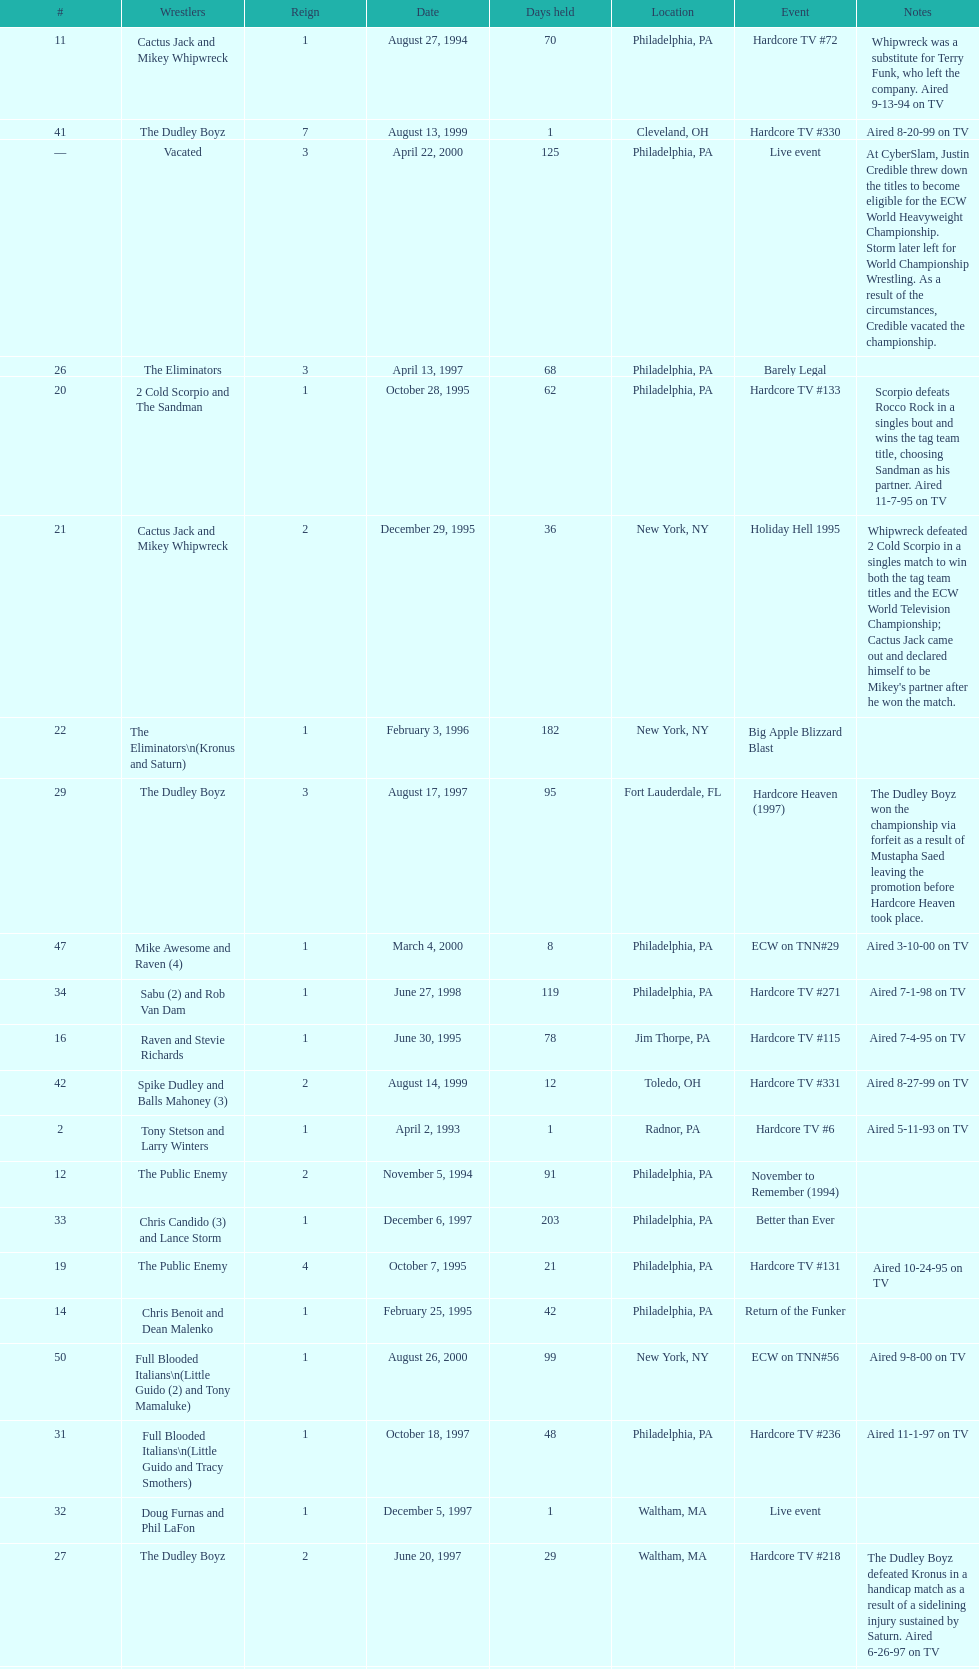What is the next event after hardcore tv #15? Hardcore TV #21. Could you parse the entire table? {'header': ['#', 'Wrestlers', 'Reign', 'Date', 'Days held', 'Location', 'Event', 'Notes'], 'rows': [['11', 'Cactus Jack and Mikey Whipwreck', '1', 'August 27, 1994', '70', 'Philadelphia, PA', 'Hardcore TV #72', 'Whipwreck was a substitute for Terry Funk, who left the company. Aired 9-13-94 on TV'], ['41', 'The Dudley Boyz', '7', 'August 13, 1999', '1', 'Cleveland, OH', 'Hardcore TV #330', 'Aired 8-20-99 on TV'], ['—', 'Vacated', '3', 'April 22, 2000', '125', 'Philadelphia, PA', 'Live event', 'At CyberSlam, Justin Credible threw down the titles to become eligible for the ECW World Heavyweight Championship. Storm later left for World Championship Wrestling. As a result of the circumstances, Credible vacated the championship.'], ['26', 'The Eliminators', '3', 'April 13, 1997', '68', 'Philadelphia, PA', 'Barely Legal', ''], ['20', '2 Cold Scorpio and The Sandman', '1', 'October 28, 1995', '62', 'Philadelphia, PA', 'Hardcore TV #133', 'Scorpio defeats Rocco Rock in a singles bout and wins the tag team title, choosing Sandman as his partner. Aired 11-7-95 on TV'], ['21', 'Cactus Jack and Mikey Whipwreck', '2', 'December 29, 1995', '36', 'New York, NY', 'Holiday Hell 1995', "Whipwreck defeated 2 Cold Scorpio in a singles match to win both the tag team titles and the ECW World Television Championship; Cactus Jack came out and declared himself to be Mikey's partner after he won the match."], ['22', 'The Eliminators\\n(Kronus and Saturn)', '1', 'February 3, 1996', '182', 'New York, NY', 'Big Apple Blizzard Blast', ''], ['29', 'The Dudley Boyz', '3', 'August 17, 1997', '95', 'Fort Lauderdale, FL', 'Hardcore Heaven (1997)', 'The Dudley Boyz won the championship via forfeit as a result of Mustapha Saed leaving the promotion before Hardcore Heaven took place.'], ['47', 'Mike Awesome and Raven (4)', '1', 'March 4, 2000', '8', 'Philadelphia, PA', 'ECW on TNN#29', 'Aired 3-10-00 on TV'], ['34', 'Sabu (2) and Rob Van Dam', '1', 'June 27, 1998', '119', 'Philadelphia, PA', 'Hardcore TV #271', 'Aired 7-1-98 on TV'], ['16', 'Raven and Stevie Richards', '1', 'June 30, 1995', '78', 'Jim Thorpe, PA', 'Hardcore TV #115', 'Aired 7-4-95 on TV'], ['42', 'Spike Dudley and Balls Mahoney (3)', '2', 'August 14, 1999', '12', 'Toledo, OH', 'Hardcore TV #331', 'Aired 8-27-99 on TV'], ['2', 'Tony Stetson and Larry Winters', '1', 'April 2, 1993', '1', 'Radnor, PA', 'Hardcore TV #6', 'Aired 5-11-93 on TV'], ['12', 'The Public Enemy', '2', 'November 5, 1994', '91', 'Philadelphia, PA', 'November to Remember (1994)', ''], ['33', 'Chris Candido (3) and Lance Storm', '1', 'December 6, 1997', '203', 'Philadelphia, PA', 'Better than Ever', ''], ['19', 'The Public Enemy', '4', 'October 7, 1995', '21', 'Philadelphia, PA', 'Hardcore TV #131', 'Aired 10-24-95 on TV'], ['14', 'Chris Benoit and Dean Malenko', '1', 'February 25, 1995', '42', 'Philadelphia, PA', 'Return of the Funker', ''], ['50', 'Full Blooded Italians\\n(Little Guido (2) and Tony Mamaluke)', '1', 'August 26, 2000', '99', 'New York, NY', 'ECW on TNN#56', 'Aired 9-8-00 on TV'], ['31', 'Full Blooded Italians\\n(Little Guido and Tracy Smothers)', '1', 'October 18, 1997', '48', 'Philadelphia, PA', 'Hardcore TV #236', 'Aired 11-1-97 on TV'], ['32', 'Doug Furnas and Phil LaFon', '1', 'December 5, 1997', '1', 'Waltham, MA', 'Live event', ''], ['27', 'The Dudley Boyz', '2', 'June 20, 1997', '29', 'Waltham, MA', 'Hardcore TV #218', 'The Dudley Boyz defeated Kronus in a handicap match as a result of a sidelining injury sustained by Saturn. Aired 6-26-97 on TV'], ['17', 'The Pitbulls\\n(Pitbull #1 and Pitbull #2)', '1', 'September 16, 1995', '21', 'Philadelphia, PA', "Gangsta's Paradise", ''], ['—', 'Vacated', '1', 'July 1993', '39', 'N/A', 'N/A', 'ECW vacated the title after Candido left the promotion for the Smoky Mountain Wrestling organization.'], ['15', 'The Public Enemy', '3', 'April 8, 1995', '83', 'Philadelphia, PA', 'Three Way Dance', 'Also def. Rick Steiner (who was a substitute for Sabu) and Taz in 3 way dance'], ['28', 'The Gangstas', '2', 'July 19, 1997', '29', 'Philadelphia, PA', 'Heat Wave 1997/Hardcore TV #222', 'Aired 7-24-97 on TV'], ['4', 'The Super Destroyers', '2', 'May 15, 1993', '0', 'Philadelphia, PA', 'Hardcore TV #14', 'Aired 7-6-93 on TV'], ['40', 'Spike Dudley and Balls Mahoney (2)', '1', 'July 18, 1999', '26', 'Dayton, OH', 'Heat Wave (1999)', ''], ['49', 'Yoshihiro Tajiri and Mikey Whipwreck (3)', '1', 'August 25, 2000', '1', 'New York, NY', 'ECW on TNN#55', 'Aired 9-1-00 on TV'], ['13', 'Sabu and The Tazmaniac (2)', '1', 'February 4, 1995', '21', 'Philadelphia, PA', 'Double Tables', ''], ['24', 'The Eliminators', '2', 'December 20, 1996', '85', 'Middletown, NY', 'Hardcore TV #193', 'Aired on 12/31/96 on Hardcore TV'], ['3', 'The Suicide Blondes\\n(Chris Candido, Johnny Hotbody, and Chris Michaels)', '1', 'April 3, 1993', '42', 'Philadelphia, PA', 'Hardcore TV #8', 'All three wrestlers were recognized as champions, and were able to defend the titles in any combination via the Freebird rule. Aired 5-25-93 on TV'], ['43', 'The Dudley Boyz', '8', 'August 26, 1999', '0', 'New York, NY', 'ECW on TNN#2', 'Aired 9-3-99 on TV'], ['1', 'The Super Destroyers\\n(A.J. Petrucci and Doug Stahl)', '1', 'June 23, 1992', '283', 'Philadelphia, PA', 'Live event', 'Petrucci and Stahl won the titles in a tournament final.'], ['6', 'The Dark Patriot and Eddie Gilbert', '1', 'August 8, 1993', '54', 'Philadelphia, PA', 'Hardcore TV #21', 'The Dark Patriot and Gilbert won the titles in a tournament final. Aired 9-7-93 on TV'], ['18', 'Raven and Stevie Richards', '2', 'October 7, 1995', '0', 'Philadelphia, PA', 'Hardcore TV #131', 'Aired 10-24-95 on TV'], ['51', 'Danny Doring and Roadkill', '1', 'December 3, 2000', '122', 'New York, NY', 'Massacre on 34th Street', "Doring and Roadkill's reign was the final one in the title's history."], ['38', 'Sabu (3) and Rob Van Dam', '2', 'December 13, 1998', '125', 'Tokyo, Japan', 'ECW/FMW Supershow II', 'Aired 12-16-98 on TV'], ['10', 'The Public Enemy\\n(Johnny Grunge and Rocco Rock)', '1', 'March 6, 1994', '174', 'Philadelphia, PA', 'Hardcore TV #46', 'Aired 3-8-94 on TV'], ['46', 'Tommy Dreamer (3) and Masato Tanaka (2)', '1', 'February 26, 2000', '7', 'Cincinnati, OH', 'Hardcore TV #358', 'Aired 3-7-00 on TV'], ['39', 'The Dudley Boyz', '6', 'April 17, 1999', '92', 'Buffalo, NY', 'Hardcore TV #313', 'D-Von Dudley defeated Van Dam in a singles match to win the championship for his team. Aired 4-23-99 on TV'], ['9', 'Kevin Sullivan and The Tazmaniac', '1', 'December 4, 1993', '92', 'Philadelphia, PA', 'Hardcore TV #35', 'Defeat Dreamer and Shane Douglas, who was substituting for an injured Gunn. After the bout, Douglas turned against Dreamer and became a heel. Aired 12-14-93 on TV'], ['36', 'Balls Mahoney and Masato Tanaka', '1', 'November 1, 1998', '5', 'New Orleans, LA', 'November to Remember (1998)', ''], ['45', 'Impact Players\\n(Justin Credible and Lance Storm (2))', '1', 'January 9, 2000', '48', 'Birmingham, AL', 'Guilty as Charged (2000)', ''], ['30', 'The Gangstanators\\n(Kronus (4) and New Jack (3))', '1', 'September 20, 1997', '28', 'Philadelphia, PA', 'As Good as it Gets', 'Aired 9-27-97 on TV'], ['8', 'Tommy Dreamer and Johnny Gunn', '1', 'November 13, 1993', '21', 'Philadelphia, PA', 'November to Remember (1993)', ''], ['5', 'The Suicide Blondes', '2', 'May 15, 1993', '46', 'Philadelphia, PA', 'Hardcore TV #15', 'Aired 7-20-93 on TV'], ['—', 'Vacated', '2', 'October 1, 1993', '0', 'Philadelphia, PA', 'Bloodfest: Part 1', 'ECW vacated the championships after The Dark Patriot and Eddie Gilbert left the organization.'], ['37', 'The Dudley Boyz', '5', 'November 6, 1998', '37', 'New York, NY', 'Hardcore TV #290', 'Aired 11-11-98 on TV'], ['7', 'Johnny Hotbody (3) and Tony Stetson (2)', '1', 'October 1, 1993', '43', 'Philadelphia, PA', 'Bloodfest: Part 1', 'Hotbody and Stetson were awarded the titles by ECW.'], ['25', 'The Dudley Boyz\\n(Buh Buh Ray Dudley and D-Von Dudley)', '1', 'March 15, 1997', '29', 'Philadelphia, PA', 'Hostile City Showdown', 'Aired 3/20/97 on Hardcore TV'], ['44', 'Tommy Dreamer (2) and Raven (3)', '1', 'August 26, 1999', '136', 'New York, NY', 'ECW on TNN#2', 'Aired 9-3-99 on TV'], ['23', 'The Gangstas\\n(Mustapha Saed and New Jack)', '1', 'August 3, 1996', '139', 'Philadelphia, PA', 'Doctor Is In', ''], ['48', 'Impact Players\\n(Justin Credible and Lance Storm (3))', '2', 'March 12, 2000', '31', 'Danbury, CT', 'Living Dangerously', ''], ['35', 'The Dudley Boyz', '4', 'October 24, 1998', '8', 'Cleveland, OH', 'Hardcore TV #288', 'Aired 10-28-98 on TV']]} 